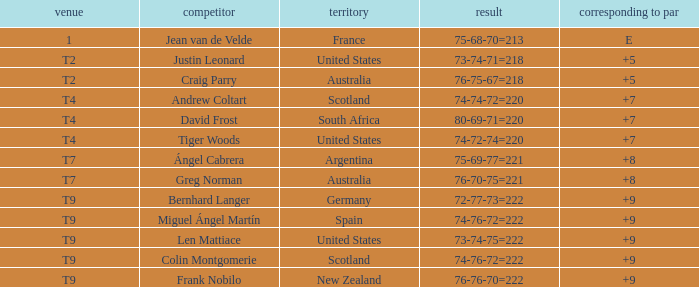What is the place number for the player with a To Par score of 'E'? 1.0. 